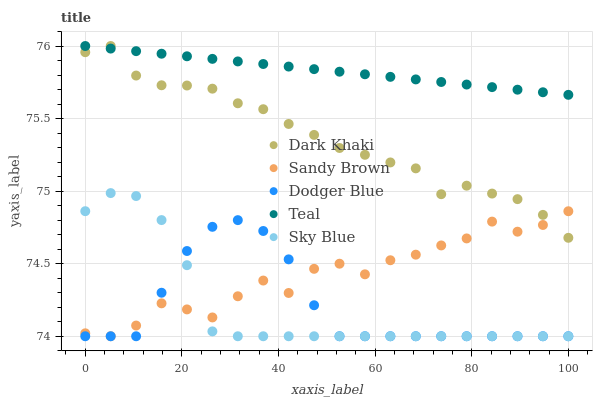Does Sky Blue have the minimum area under the curve?
Answer yes or no. Yes. Does Teal have the maximum area under the curve?
Answer yes or no. Yes. Does Dodger Blue have the minimum area under the curve?
Answer yes or no. No. Does Dodger Blue have the maximum area under the curve?
Answer yes or no. No. Is Teal the smoothest?
Answer yes or no. Yes. Is Sandy Brown the roughest?
Answer yes or no. Yes. Is Dodger Blue the smoothest?
Answer yes or no. No. Is Dodger Blue the roughest?
Answer yes or no. No. Does Dodger Blue have the lowest value?
Answer yes or no. Yes. Does Teal have the lowest value?
Answer yes or no. No. Does Teal have the highest value?
Answer yes or no. Yes. Does Sandy Brown have the highest value?
Answer yes or no. No. Is Sandy Brown less than Teal?
Answer yes or no. Yes. Is Dark Khaki greater than Dodger Blue?
Answer yes or no. Yes. Does Teal intersect Dark Khaki?
Answer yes or no. Yes. Is Teal less than Dark Khaki?
Answer yes or no. No. Is Teal greater than Dark Khaki?
Answer yes or no. No. Does Sandy Brown intersect Teal?
Answer yes or no. No. 